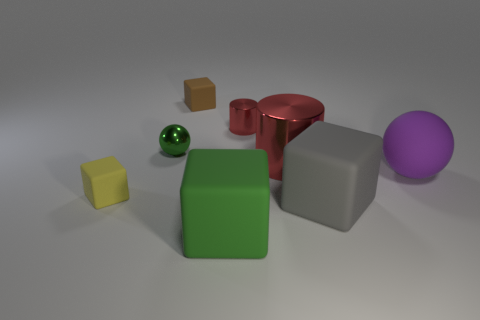There is another cylinder that is the same color as the large metal cylinder; what is its size?
Provide a short and direct response. Small. The brown rubber object has what size?
Offer a very short reply. Small. There is a large green object; what shape is it?
Your answer should be very brief. Cube. There is a purple matte thing; is it the same shape as the matte thing that is to the left of the brown matte cube?
Make the answer very short. No. Does the small brown matte thing that is on the right side of the green metallic ball have the same shape as the big green matte object?
Offer a terse response. Yes. How many matte cubes are both left of the large shiny thing and in front of the tiny yellow thing?
Your answer should be compact. 1. How many other things are the same size as the gray matte thing?
Your response must be concise. 3. Are there an equal number of gray objects that are to the left of the big red object and brown rubber blocks?
Your answer should be very brief. No. There is a small matte block that is behind the tiny green ball; is it the same color as the ball that is on the left side of the big metal cylinder?
Make the answer very short. No. There is a big thing that is both in front of the purple rubber sphere and on the left side of the large gray object; what is its material?
Your answer should be very brief. Rubber. 